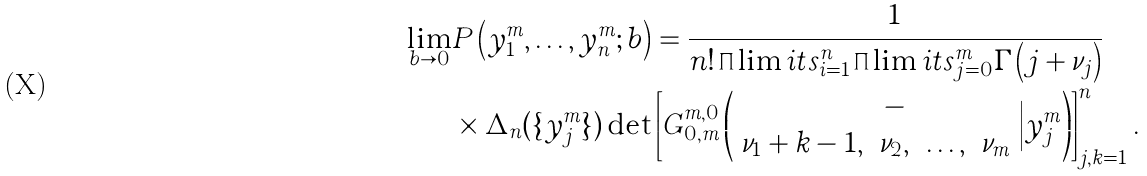<formula> <loc_0><loc_0><loc_500><loc_500>\underset { b \rightarrow 0 } { \lim } & P \left ( y _ { 1 } ^ { m } , \dots , y _ { n } ^ { m } ; b \right ) = \frac { 1 } { n ! \prod \lim i t s _ { i = 1 } ^ { n } \prod \lim i t s _ { j = 0 } ^ { m } \Gamma \left ( j + \nu _ { j } \right ) } \\ & \times \Delta _ { n } ( \{ y _ { j } ^ { m } \} ) \det \left [ G ^ { m , 0 } _ { 0 , m } \left ( \begin{array} { c c c c } & - & & \\ \nu _ { 1 } + k - 1 , & \nu _ { 2 } , & \dots , & \nu _ { m } \end{array} \Big | y _ { j } ^ { m } \right ) \right ] _ { j , k = 1 } ^ { n } .</formula> 